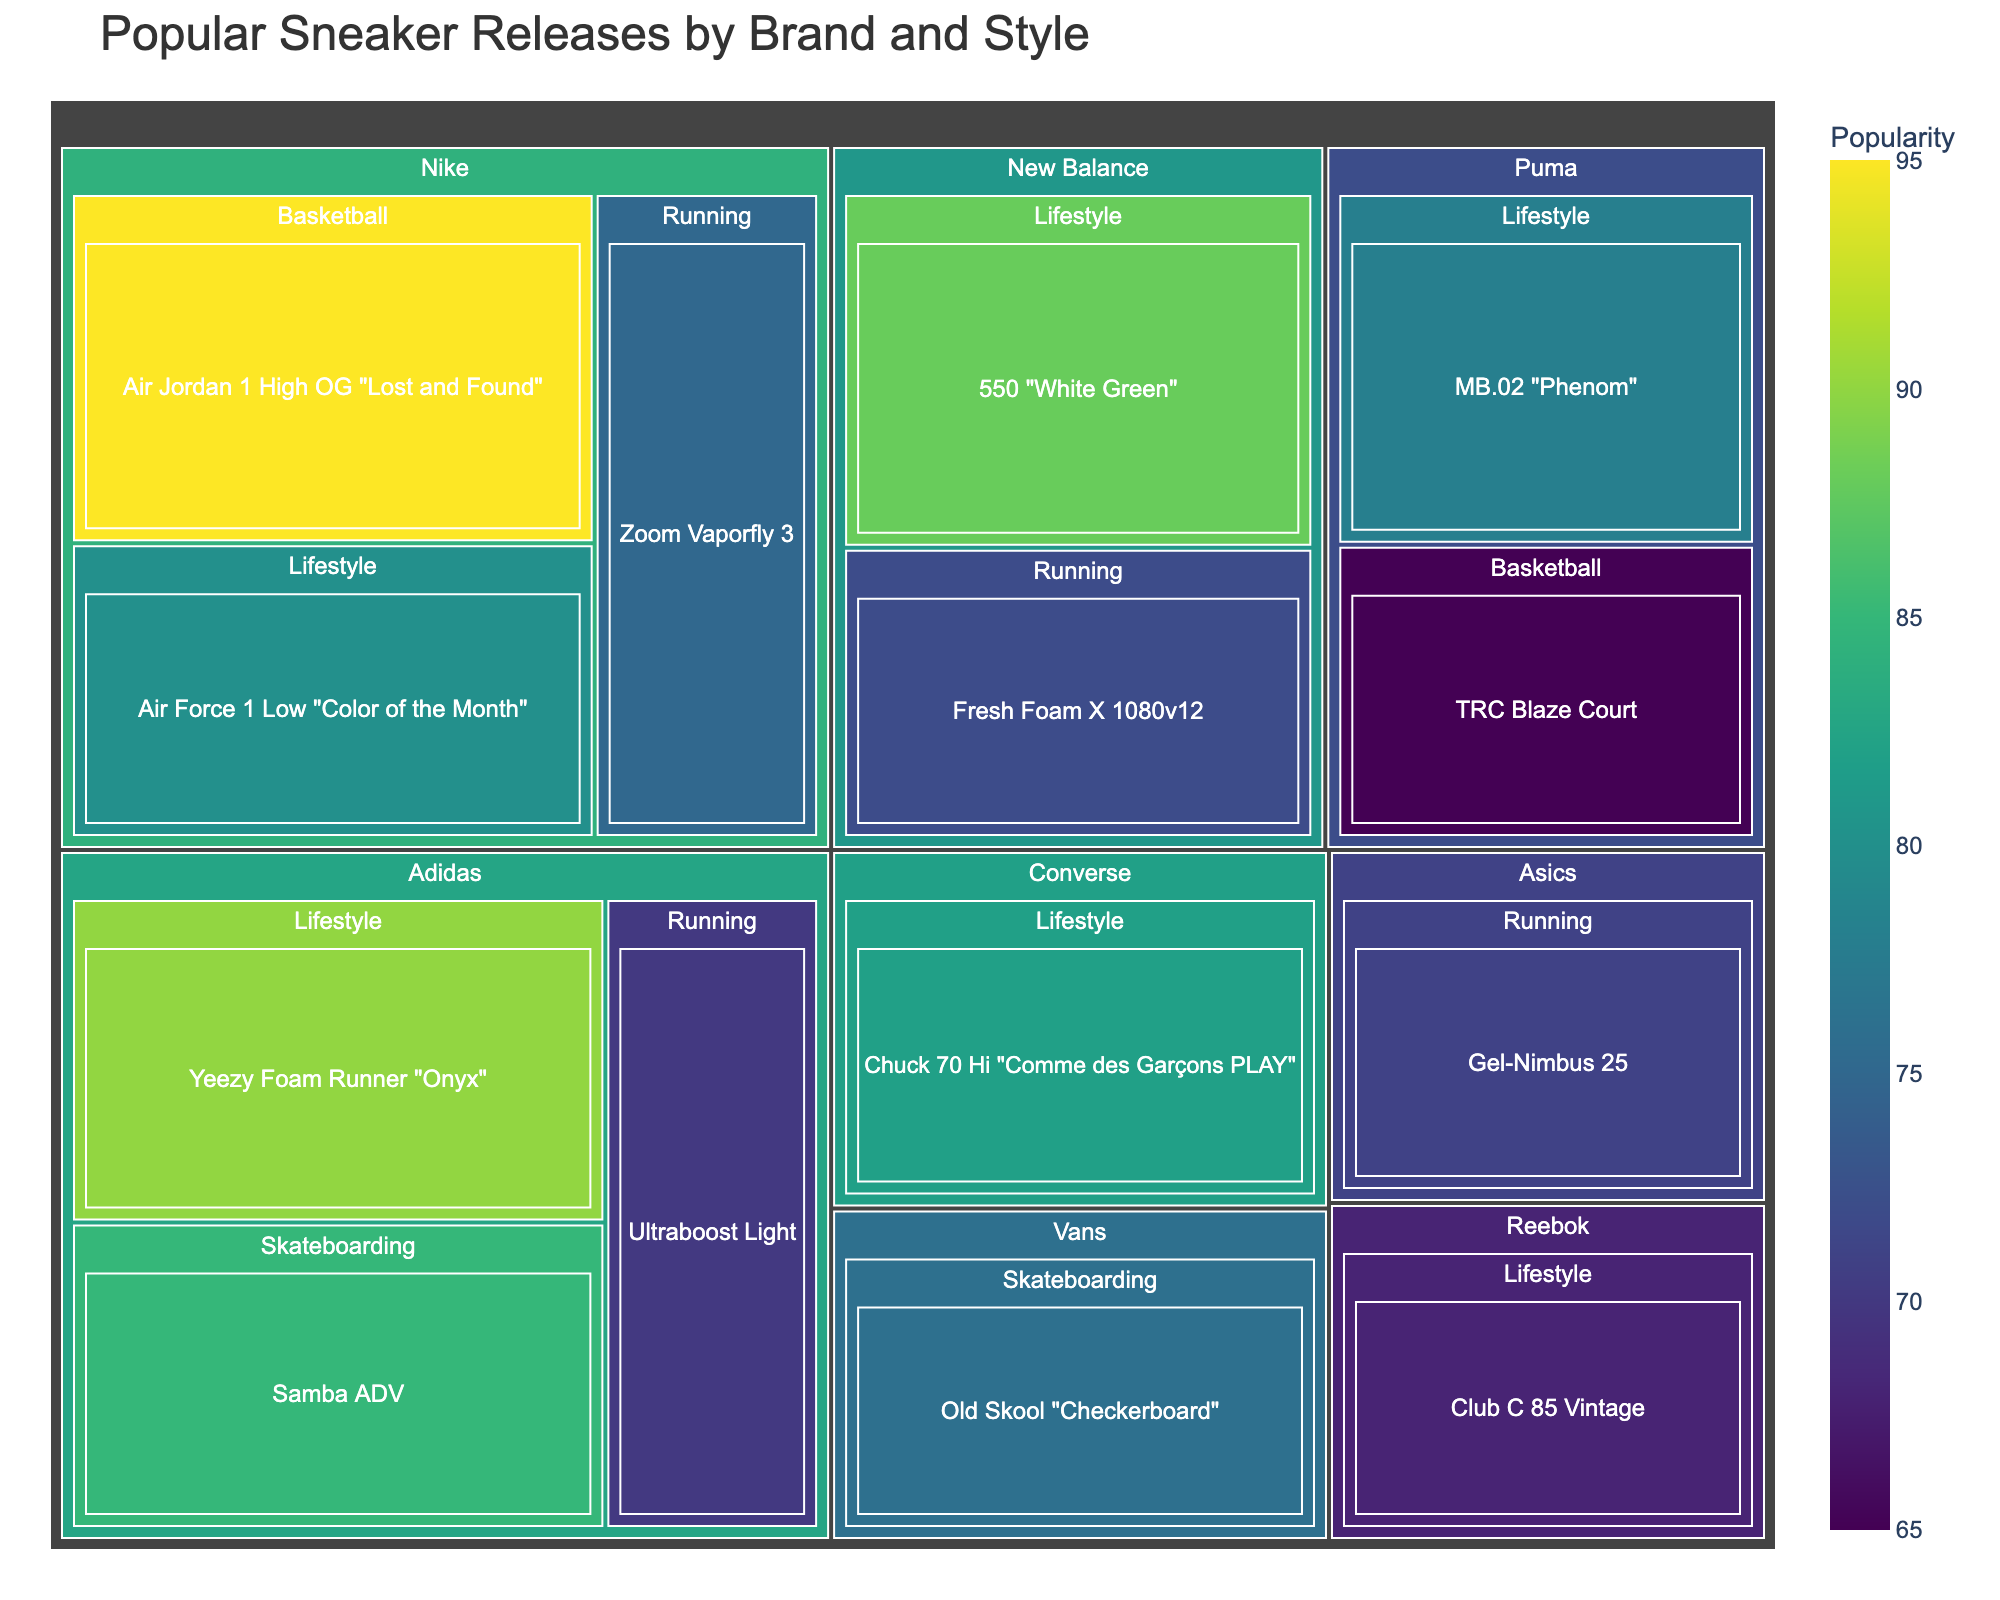what is the most popular sneaker release of the year? The treemap shows the popularity of each sneaker model, and the model with the highest popularity will appear the largest and possibly darkest in color. Specifically, we can identify the Air Jordan 1 High OG "Lost and Found" from Nike under the Basketball style with a popularity of 95.
Answer: Air Jordan 1 High OG "Lost and Found" Which brand has the highest overall popularity in sneaker releases? The treemap allows for visual comparison across brands. Nike has multiple shoe models with high popularity scores (such as the Air Jordan 1 High OG "Lost and Found" with 95) and sizeable representation in multiple categories, showing Nike as the brand with the highest overall popularity.
Answer: Nike How many brands are represented in the treemap? The treemap categorizes the data first by "Brand," each brand is a primary section, and you can count the distinct sections for brands. From the given data, there are Nike, Adidas, New Balance, Puma, Converse, Vans, and Reebok, totaling 7 brands.
Answer: 7 Which model under the Adidas brand has the highest popularity? Navigate to the section labeled "Adidas" in the treemap and compare the popularity scores of the models listed under Adidas. The Yeezy Foam Runner "Onyx" with a popularity score of 90 is the highest under Adidas.
Answer: Yeezy Foam Runner "Onyx" What is the average popularity score of Nike's Lifestyle sneaker releases? From the Nike section for Lifestyle sneakers, we have two models: Air Force 1 Low "Color of the Month" with a popularity score of 80 and Zoom Vaporfly 3 with 75. To find the average: (80 + 75) / 2 = 155 / 2 = 77.5
Answer: 77.5 Which style category has the most models in the treemap? The treemap groups sneakers by style under each brand. Counting the models in each style category (Basketball, Lifestyle, Running, Skateboarding), Lifestyle has the most models listed (6 models across brands Nike, Adidas, Puma, Converse, Reebok).
Answer: Lifestyle Which sneaker model under Running style from New Balance is represented, and what is its popularity score? Find the New Balance section, and within that, the part labeled Running. The model under this category is Fresh Foam X 1080v12, which has a popularity score of 72.
Answer: Fresh Foam X 1080v12 with a score of 72 Compare the popularity scores of the Adidas Ultraboost Light and the New Balance Fresh Foam X 1080v12. Which one is more popular? Locate both models under their respective brands and styles. Adidas Ultraboost Light has a popularity of 70, while New Balance Fresh Foam X 1080v12 has a popularity of 72. Comparing these values, the New Balance model is more popular.
Answer: New Balance Fresh Foam X 1080v12 How does the popularity score of the Puma TRC Blaze Court compare to that of the Vans Old Skool "Checkerboard"? Locate the Puma TRC Blaze Court under Puma's Basketball section with a popularity of 65. Then, find the Vans Old Skool "Checkerboard" under Vans' Skateboarding section with a popularity of 76. The Vans model is more popular.
Answer: Vans Old Skool "Checkerboard" is more popular Which brand and style combination has the model with the worst (lowest) popularity score in the treemap, and what is that score? Identify the models with the lowest scores by scanning through the treemap. The lowest score is under Puma's Basketball section, the TRC Blaze Court, with a popularity score of 65.
Answer: Puma Basketball with a score of 65 